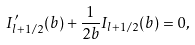Convert formula to latex. <formula><loc_0><loc_0><loc_500><loc_500>I _ { l + 1 / 2 } ^ { \prime } ( b ) + \frac { 1 } { 2 b } I _ { l + 1 / 2 } ( b ) = 0 ,</formula> 